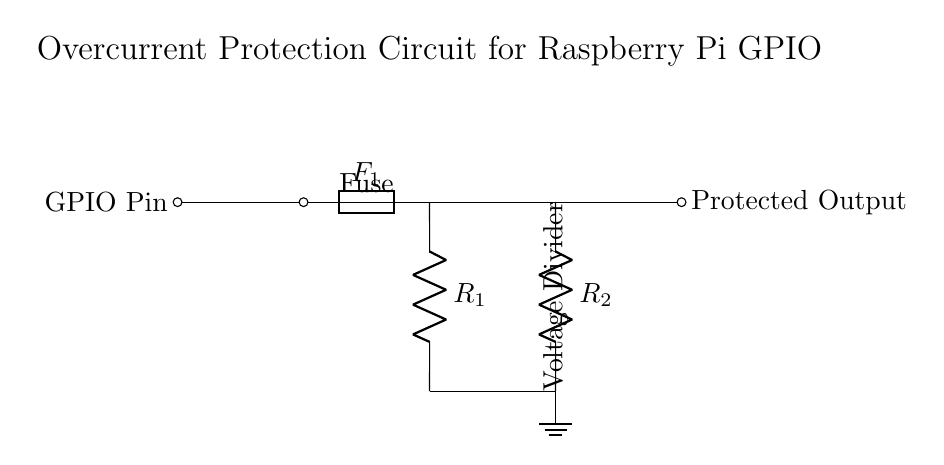What component provides overcurrent protection? The circuit includes a fuse labeled F1, which is designed to interrupt the circuit when excessive current flows through it, hence providing protection against overcurrent conditions.
Answer: Fuse What are the resistor values in the voltage divider? The circuit diagram shows two resistors labeled R1 and R2, but their specific values are not indicated in the diagram itself; they would need to be provided elsewhere in the design documentation or decided by the user based on the desired output voltage.
Answer: Not specified What does the protected output connect to? The diagram indicates that the protected output connects to the right side of the voltage divider, suggesting that it supplies the already protected voltage signal to the connected component or application.
Answer: Protected Output How many resistors are in the circuit? There are two resistors present in the circuit, R1 and R2, which form a voltage divider to condition the voltage after the fuse protection.
Answer: Two Why is a voltage divider used in this circuit? The voltage divider in this circuit serves to reduce and regulate the voltage level after the overcurrent protection from the fuse. This ensures that the output voltage does not exceed the voltage tolerance of the Raspberry Pi GPIO pins.
Answer: To regulate voltage What is the purpose of the ground connection? The ground connection in the circuit provides a reference point for the voltages within the circuit and ensures a complete path for current flow, which is essential for proper operation and safety in electronic circuits.
Answer: Reference point What label identifies the GPIO pin? The GPIO pin is identified by a label "GPIO Pin" which is located on the left side of the circuit diagram, indicating the input from the Raspberry Pi to the protection circuit.
Answer: GPIO Pin 